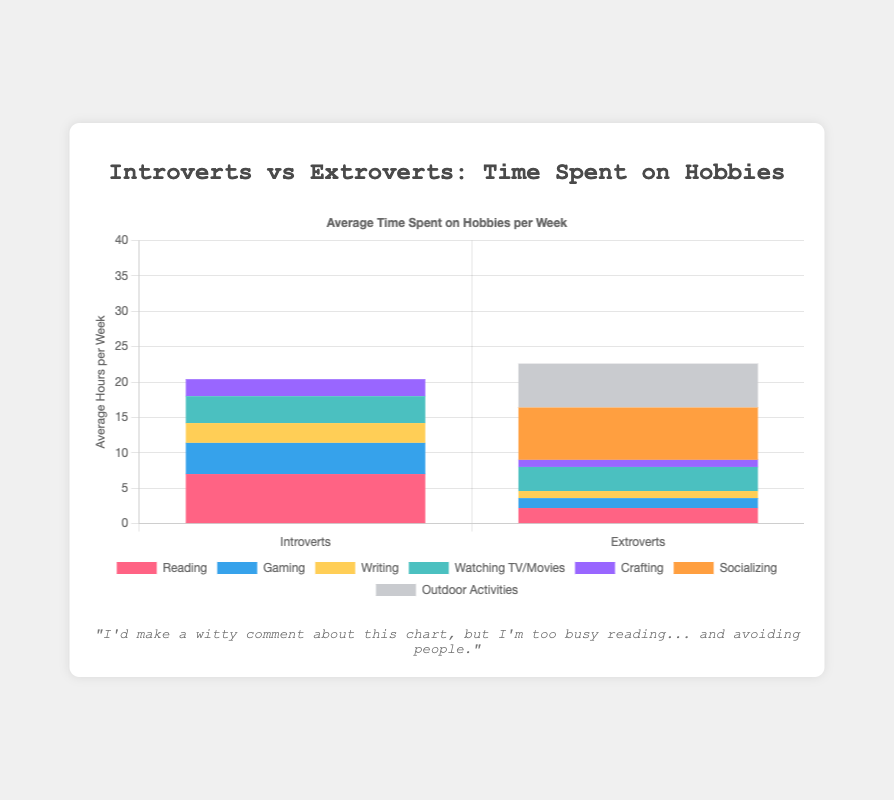Which group spends more time on reading, introverts or extroverts? Introverts and extroverts have separate bars for reading. The red bar representing reading for introverts is taller than the one for extroverts.
Answer: Introverts How much more time do extroverts spend on socializing compared to introverts? Introverts do not have a bar for socializing, indicating they spend zero hours. The socializing bar for extroverts is around 7.4 average hours per week. Difference is 7.4 - 0.
Answer: 7.4 hours Which activity do introverts spend the least time on? Among the activities listed for introverts, crafting has the shortest purple bar, indicating the least amount of time spent.
Answer: Crafting Which activity has the highest average weekly hours for extroverts? Extroverts have the tallest orange bar for socializing, making it the activity with the highest average weekly hours.
Answer: Socializing What is the combined average weekly time spent on outdoor activities and socializing for extroverts? Extroverts have around 7.4 hours for socializing and about 6.2 hours for outdoor activities. Summing these gives 7.4 + 6.2.
Answer: 13.6 hours Do introverts or extroverts spend more time on watching TV/movies? Both introverts and extroverts have a similar height turquoise bar for watching TV/movies. Evaluating visually, they appear equal.
Answer: Equal Which group spends more time on writing, introverts or extroverts? The yellow bar for writing is taller for introverts compared to extroverts, indicating more time spent by introverts.
Answer: Introverts By how much do introverts' average weekly reading hours exceed extroverts'? Introverts have around 7 hours average reading, while extroverts have around 2.2 hours. Difference is 7 - 2.2.
Answer: 4.8 hours What is the average time spent on crafting by both introverts and extroverts combined? Introverts' crafting bar is around 2.4 hours, extroverts' is about 1. Combining, we get (2.4 + 1) / 2.
Answer: 1.7 hours Which activity has the closest average weekly hours between introverts and extroverts? The turquoise bars for watching TV/movies are nearly identical in height, indicating the closest average weekly hours between both groups.
Answer: Watching TV/Movies 